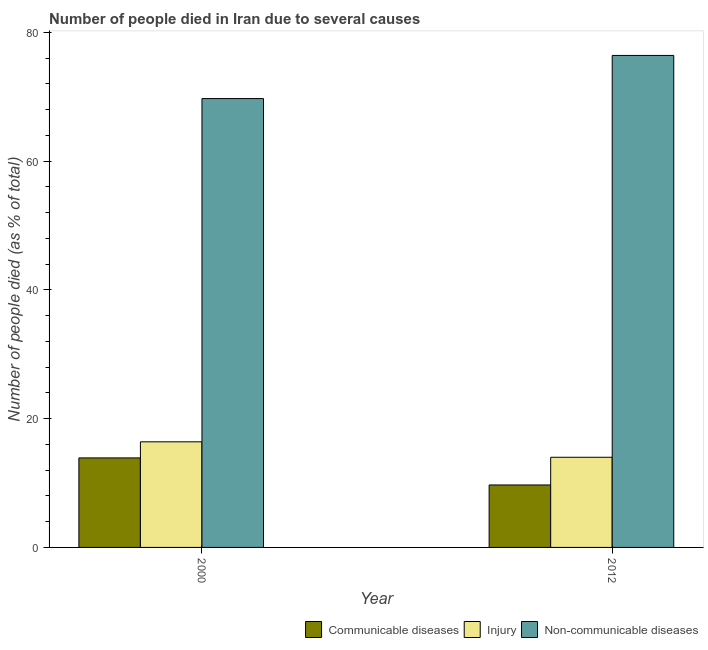How many different coloured bars are there?
Your answer should be compact. 3. Are the number of bars per tick equal to the number of legend labels?
Your answer should be compact. Yes. How many bars are there on the 2nd tick from the right?
Your response must be concise. 3. What is the label of the 1st group of bars from the left?
Make the answer very short. 2000. In how many cases, is the number of bars for a given year not equal to the number of legend labels?
Make the answer very short. 0. Across all years, what is the maximum number of people who dies of non-communicable diseases?
Your answer should be very brief. 76.4. Across all years, what is the minimum number of people who died of injury?
Ensure brevity in your answer.  14. In which year was the number of people who died of communicable diseases maximum?
Provide a short and direct response. 2000. What is the total number of people who died of injury in the graph?
Your answer should be very brief. 30.4. What is the difference between the number of people who dies of non-communicable diseases in 2000 and that in 2012?
Your response must be concise. -6.7. What is the difference between the number of people who dies of non-communicable diseases in 2000 and the number of people who died of communicable diseases in 2012?
Make the answer very short. -6.7. What is the average number of people who died of communicable diseases per year?
Offer a terse response. 11.8. In how many years, is the number of people who died of communicable diseases greater than 48 %?
Give a very brief answer. 0. What is the ratio of the number of people who died of injury in 2000 to that in 2012?
Keep it short and to the point. 1.17. What does the 1st bar from the left in 2000 represents?
Ensure brevity in your answer.  Communicable diseases. What does the 1st bar from the right in 2000 represents?
Your answer should be very brief. Non-communicable diseases. How many bars are there?
Offer a very short reply. 6. How many years are there in the graph?
Your answer should be compact. 2. Are the values on the major ticks of Y-axis written in scientific E-notation?
Provide a short and direct response. No. Does the graph contain any zero values?
Give a very brief answer. No. Does the graph contain grids?
Your answer should be very brief. No. How many legend labels are there?
Keep it short and to the point. 3. How are the legend labels stacked?
Your answer should be very brief. Horizontal. What is the title of the graph?
Provide a succinct answer. Number of people died in Iran due to several causes. Does "Interest" appear as one of the legend labels in the graph?
Make the answer very short. No. What is the label or title of the X-axis?
Your response must be concise. Year. What is the label or title of the Y-axis?
Give a very brief answer. Number of people died (as % of total). What is the Number of people died (as % of total) in Communicable diseases in 2000?
Ensure brevity in your answer.  13.9. What is the Number of people died (as % of total) in Injury in 2000?
Provide a succinct answer. 16.4. What is the Number of people died (as % of total) of Non-communicable diseases in 2000?
Provide a short and direct response. 69.7. What is the Number of people died (as % of total) of Non-communicable diseases in 2012?
Provide a succinct answer. 76.4. Across all years, what is the maximum Number of people died (as % of total) of Communicable diseases?
Make the answer very short. 13.9. Across all years, what is the maximum Number of people died (as % of total) of Injury?
Your response must be concise. 16.4. Across all years, what is the maximum Number of people died (as % of total) of Non-communicable diseases?
Your answer should be compact. 76.4. Across all years, what is the minimum Number of people died (as % of total) in Communicable diseases?
Provide a short and direct response. 9.7. Across all years, what is the minimum Number of people died (as % of total) in Non-communicable diseases?
Give a very brief answer. 69.7. What is the total Number of people died (as % of total) in Communicable diseases in the graph?
Provide a short and direct response. 23.6. What is the total Number of people died (as % of total) in Injury in the graph?
Provide a short and direct response. 30.4. What is the total Number of people died (as % of total) in Non-communicable diseases in the graph?
Your response must be concise. 146.1. What is the difference between the Number of people died (as % of total) in Communicable diseases in 2000 and that in 2012?
Keep it short and to the point. 4.2. What is the difference between the Number of people died (as % of total) in Communicable diseases in 2000 and the Number of people died (as % of total) in Non-communicable diseases in 2012?
Your answer should be very brief. -62.5. What is the difference between the Number of people died (as % of total) in Injury in 2000 and the Number of people died (as % of total) in Non-communicable diseases in 2012?
Your answer should be very brief. -60. What is the average Number of people died (as % of total) of Injury per year?
Provide a succinct answer. 15.2. What is the average Number of people died (as % of total) of Non-communicable diseases per year?
Your answer should be very brief. 73.05. In the year 2000, what is the difference between the Number of people died (as % of total) in Communicable diseases and Number of people died (as % of total) in Injury?
Your answer should be very brief. -2.5. In the year 2000, what is the difference between the Number of people died (as % of total) of Communicable diseases and Number of people died (as % of total) of Non-communicable diseases?
Offer a very short reply. -55.8. In the year 2000, what is the difference between the Number of people died (as % of total) in Injury and Number of people died (as % of total) in Non-communicable diseases?
Offer a very short reply. -53.3. In the year 2012, what is the difference between the Number of people died (as % of total) in Communicable diseases and Number of people died (as % of total) in Non-communicable diseases?
Your answer should be compact. -66.7. In the year 2012, what is the difference between the Number of people died (as % of total) of Injury and Number of people died (as % of total) of Non-communicable diseases?
Offer a very short reply. -62.4. What is the ratio of the Number of people died (as % of total) in Communicable diseases in 2000 to that in 2012?
Make the answer very short. 1.43. What is the ratio of the Number of people died (as % of total) of Injury in 2000 to that in 2012?
Your answer should be compact. 1.17. What is the ratio of the Number of people died (as % of total) of Non-communicable diseases in 2000 to that in 2012?
Offer a terse response. 0.91. What is the difference between the highest and the lowest Number of people died (as % of total) in Non-communicable diseases?
Provide a short and direct response. 6.7. 